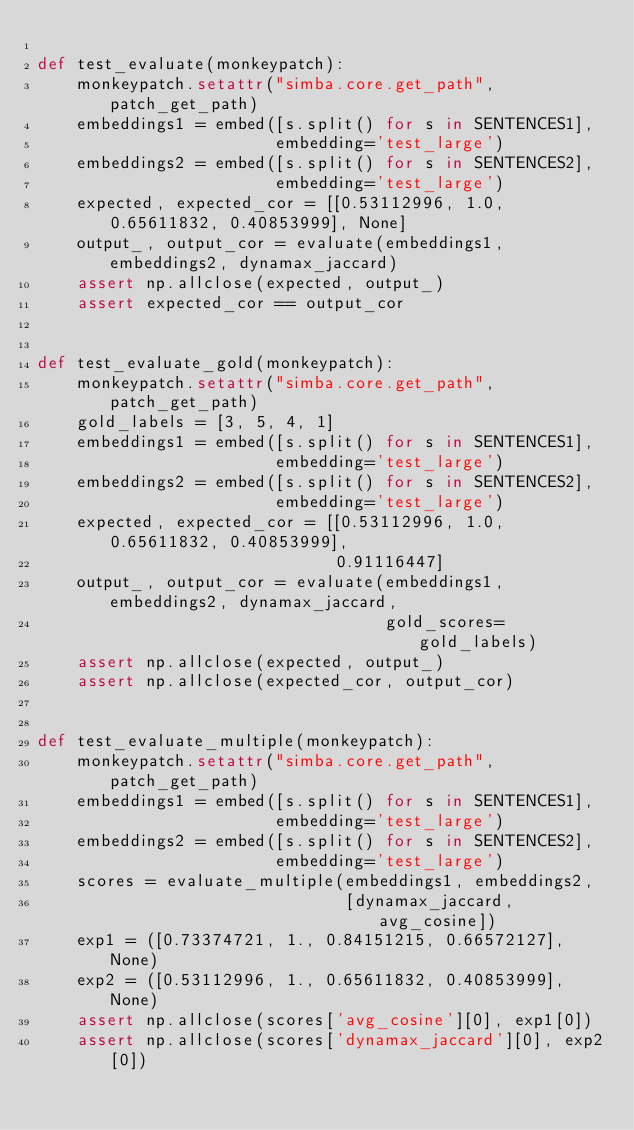Convert code to text. <code><loc_0><loc_0><loc_500><loc_500><_Python_>
def test_evaluate(monkeypatch):
    monkeypatch.setattr("simba.core.get_path", patch_get_path)
    embeddings1 = embed([s.split() for s in SENTENCES1],
                        embedding='test_large')
    embeddings2 = embed([s.split() for s in SENTENCES2],
                        embedding='test_large')
    expected, expected_cor = [[0.53112996, 1.0, 0.65611832, 0.40853999], None]
    output_, output_cor = evaluate(embeddings1, embeddings2, dynamax_jaccard)
    assert np.allclose(expected, output_)
    assert expected_cor == output_cor


def test_evaluate_gold(monkeypatch):
    monkeypatch.setattr("simba.core.get_path", patch_get_path)
    gold_labels = [3, 5, 4, 1]
    embeddings1 = embed([s.split() for s in SENTENCES1],
                        embedding='test_large')
    embeddings2 = embed([s.split() for s in SENTENCES2],
                        embedding='test_large')
    expected, expected_cor = [[0.53112996, 1.0, 0.65611832, 0.40853999],
                              0.91116447]
    output_, output_cor = evaluate(embeddings1, embeddings2, dynamax_jaccard,
                                   gold_scores=gold_labels)
    assert np.allclose(expected, output_)
    assert np.allclose(expected_cor, output_cor)


def test_evaluate_multiple(monkeypatch):
    monkeypatch.setattr("simba.core.get_path", patch_get_path)
    embeddings1 = embed([s.split() for s in SENTENCES1],
                        embedding='test_large')
    embeddings2 = embed([s.split() for s in SENTENCES2],
                        embedding='test_large')
    scores = evaluate_multiple(embeddings1, embeddings2,
                               [dynamax_jaccard, avg_cosine])
    exp1 = ([0.73374721, 1., 0.84151215, 0.66572127], None)
    exp2 = ([0.53112996, 1., 0.65611832, 0.40853999], None)
    assert np.allclose(scores['avg_cosine'][0], exp1[0])
    assert np.allclose(scores['dynamax_jaccard'][0], exp2[0])
</code> 